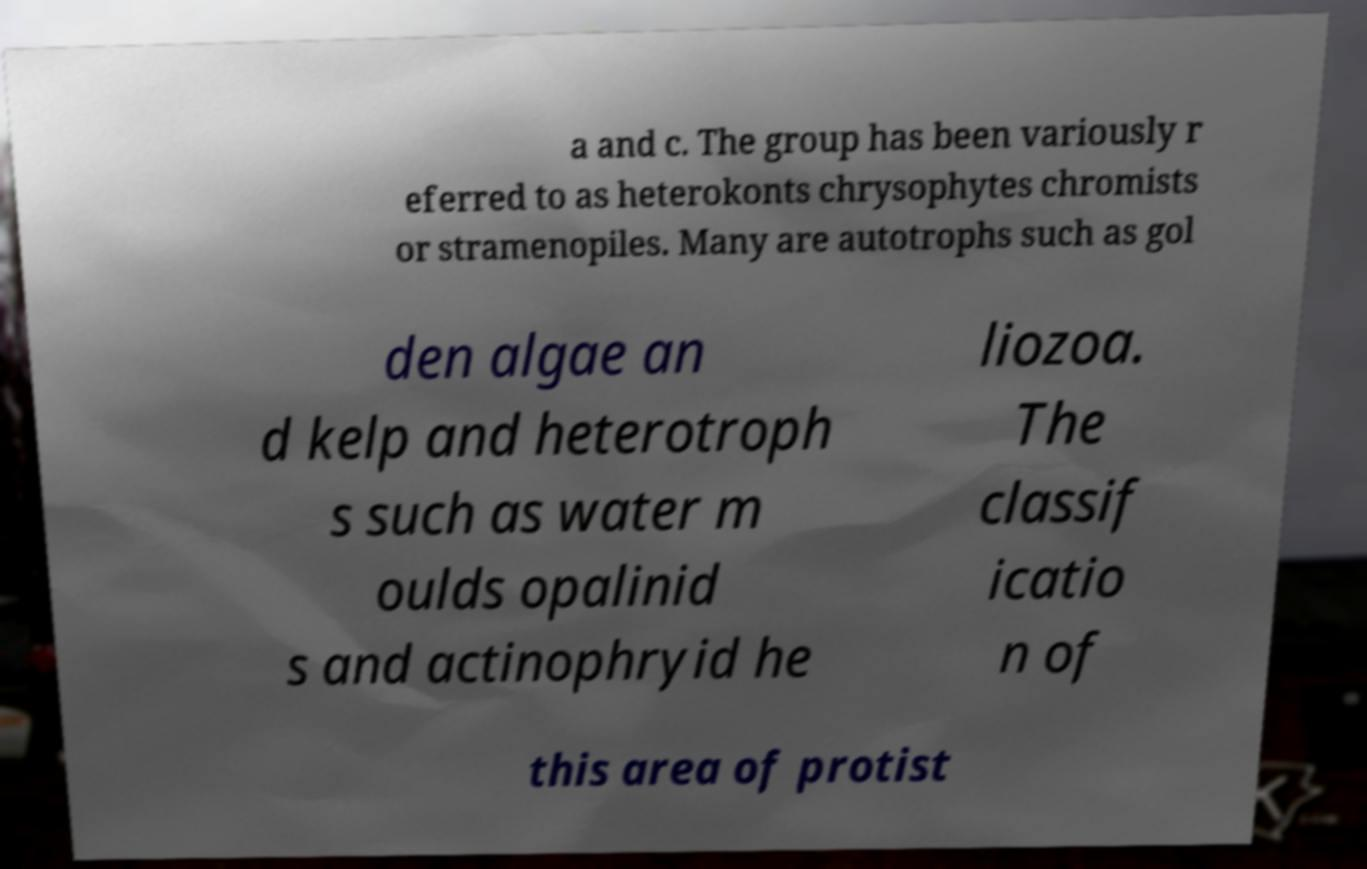What messages or text are displayed in this image? I need them in a readable, typed format. a and c. The group has been variously r eferred to as heterokonts chrysophytes chromists or stramenopiles. Many are autotrophs such as gol den algae an d kelp and heterotroph s such as water m oulds opalinid s and actinophryid he liozoa. The classif icatio n of this area of protist 